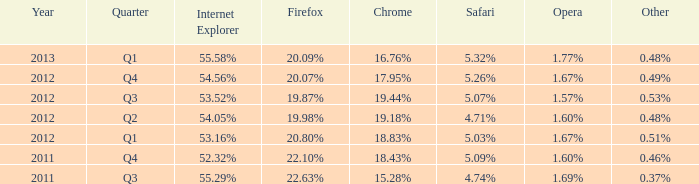During the 2012 q1 period, which internet explorer version had an opera-equivalent market share of 1.67%? 53.16%. 